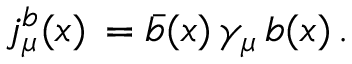<formula> <loc_0><loc_0><loc_500><loc_500>j _ { \mu } ^ { b } ( x ) \, = \bar { b } ( x ) \, \gamma _ { \mu } \, b ( x ) \, .</formula> 